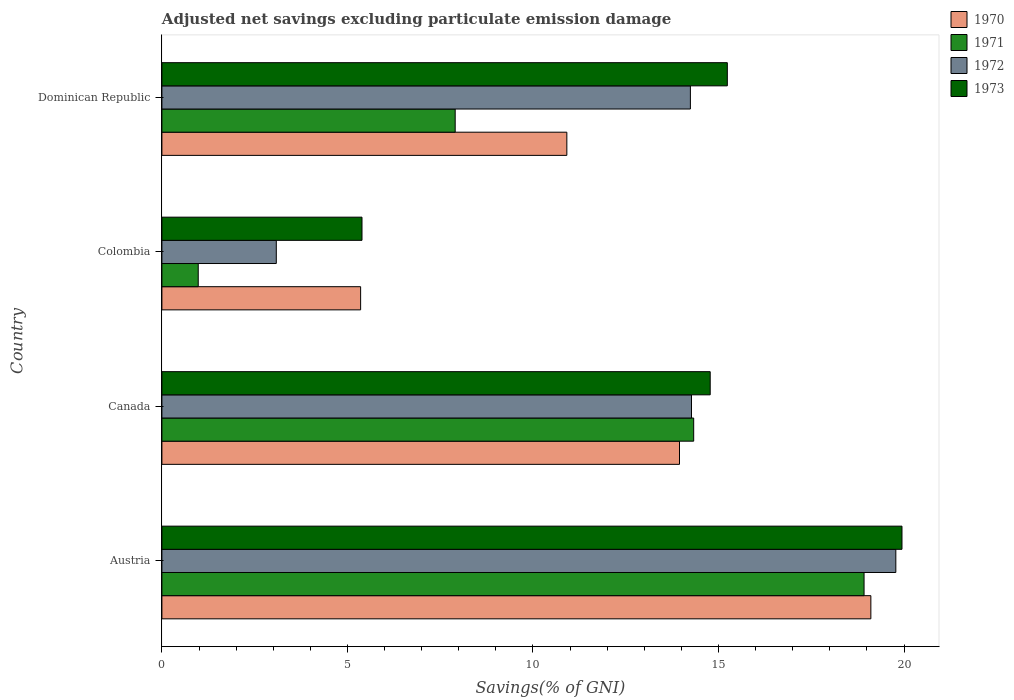How many different coloured bars are there?
Make the answer very short. 4. How many groups of bars are there?
Keep it short and to the point. 4. Are the number of bars per tick equal to the number of legend labels?
Make the answer very short. Yes. Are the number of bars on each tick of the Y-axis equal?
Offer a very short reply. Yes. How many bars are there on the 1st tick from the bottom?
Your answer should be compact. 4. What is the adjusted net savings in 1973 in Dominican Republic?
Keep it short and to the point. 15.24. Across all countries, what is the maximum adjusted net savings in 1971?
Provide a succinct answer. 18.92. Across all countries, what is the minimum adjusted net savings in 1972?
Your answer should be compact. 3.08. What is the total adjusted net savings in 1973 in the graph?
Offer a terse response. 55.35. What is the difference between the adjusted net savings in 1972 in Austria and that in Dominican Republic?
Provide a succinct answer. 5.54. What is the difference between the adjusted net savings in 1971 in Dominican Republic and the adjusted net savings in 1970 in Austria?
Your answer should be compact. -11.2. What is the average adjusted net savings in 1971 per country?
Ensure brevity in your answer.  10.53. What is the difference between the adjusted net savings in 1973 and adjusted net savings in 1970 in Austria?
Give a very brief answer. 0.84. In how many countries, is the adjusted net savings in 1972 greater than 12 %?
Keep it short and to the point. 3. What is the ratio of the adjusted net savings in 1972 in Canada to that in Colombia?
Offer a terse response. 4.63. Is the adjusted net savings in 1973 in Canada less than that in Dominican Republic?
Ensure brevity in your answer.  Yes. Is the difference between the adjusted net savings in 1973 in Canada and Colombia greater than the difference between the adjusted net savings in 1970 in Canada and Colombia?
Ensure brevity in your answer.  Yes. What is the difference between the highest and the second highest adjusted net savings in 1972?
Provide a succinct answer. 5.51. What is the difference between the highest and the lowest adjusted net savings in 1971?
Your answer should be compact. 17.94. Is the sum of the adjusted net savings in 1971 in Canada and Dominican Republic greater than the maximum adjusted net savings in 1972 across all countries?
Give a very brief answer. Yes. Is it the case that in every country, the sum of the adjusted net savings in 1970 and adjusted net savings in 1972 is greater than the sum of adjusted net savings in 1971 and adjusted net savings in 1973?
Your response must be concise. No. What does the 3rd bar from the top in Colombia represents?
Your answer should be very brief. 1971. What does the 3rd bar from the bottom in Dominican Republic represents?
Make the answer very short. 1972. How many bars are there?
Offer a very short reply. 16. Are all the bars in the graph horizontal?
Offer a very short reply. Yes. How many countries are there in the graph?
Give a very brief answer. 4. Are the values on the major ticks of X-axis written in scientific E-notation?
Make the answer very short. No. Does the graph contain any zero values?
Your response must be concise. No. Where does the legend appear in the graph?
Offer a terse response. Top right. What is the title of the graph?
Make the answer very short. Adjusted net savings excluding particulate emission damage. What is the label or title of the X-axis?
Ensure brevity in your answer.  Savings(% of GNI). What is the label or title of the Y-axis?
Offer a very short reply. Country. What is the Savings(% of GNI) of 1970 in Austria?
Provide a short and direct response. 19.11. What is the Savings(% of GNI) in 1971 in Austria?
Your answer should be very brief. 18.92. What is the Savings(% of GNI) of 1972 in Austria?
Offer a terse response. 19.78. What is the Savings(% of GNI) of 1973 in Austria?
Your answer should be compact. 19.94. What is the Savings(% of GNI) in 1970 in Canada?
Provide a succinct answer. 13.95. What is the Savings(% of GNI) of 1971 in Canada?
Ensure brevity in your answer.  14.33. What is the Savings(% of GNI) in 1972 in Canada?
Your response must be concise. 14.27. What is the Savings(% of GNI) in 1973 in Canada?
Your answer should be compact. 14.78. What is the Savings(% of GNI) in 1970 in Colombia?
Ensure brevity in your answer.  5.36. What is the Savings(% of GNI) in 1971 in Colombia?
Give a very brief answer. 0.98. What is the Savings(% of GNI) in 1972 in Colombia?
Ensure brevity in your answer.  3.08. What is the Savings(% of GNI) of 1973 in Colombia?
Offer a very short reply. 5.39. What is the Savings(% of GNI) of 1970 in Dominican Republic?
Provide a succinct answer. 10.91. What is the Savings(% of GNI) in 1971 in Dominican Republic?
Your answer should be compact. 7.9. What is the Savings(% of GNI) in 1972 in Dominican Republic?
Your response must be concise. 14.24. What is the Savings(% of GNI) in 1973 in Dominican Republic?
Your answer should be compact. 15.24. Across all countries, what is the maximum Savings(% of GNI) in 1970?
Your response must be concise. 19.11. Across all countries, what is the maximum Savings(% of GNI) in 1971?
Give a very brief answer. 18.92. Across all countries, what is the maximum Savings(% of GNI) in 1972?
Your answer should be very brief. 19.78. Across all countries, what is the maximum Savings(% of GNI) in 1973?
Ensure brevity in your answer.  19.94. Across all countries, what is the minimum Savings(% of GNI) of 1970?
Keep it short and to the point. 5.36. Across all countries, what is the minimum Savings(% of GNI) in 1971?
Give a very brief answer. 0.98. Across all countries, what is the minimum Savings(% of GNI) of 1972?
Provide a short and direct response. 3.08. Across all countries, what is the minimum Savings(% of GNI) in 1973?
Provide a short and direct response. 5.39. What is the total Savings(% of GNI) of 1970 in the graph?
Make the answer very short. 49.32. What is the total Savings(% of GNI) of 1971 in the graph?
Your answer should be very brief. 42.14. What is the total Savings(% of GNI) in 1972 in the graph?
Keep it short and to the point. 51.38. What is the total Savings(% of GNI) of 1973 in the graph?
Keep it short and to the point. 55.35. What is the difference between the Savings(% of GNI) in 1970 in Austria and that in Canada?
Your response must be concise. 5.16. What is the difference between the Savings(% of GNI) in 1971 in Austria and that in Canada?
Offer a very short reply. 4.59. What is the difference between the Savings(% of GNI) of 1972 in Austria and that in Canada?
Ensure brevity in your answer.  5.51. What is the difference between the Savings(% of GNI) of 1973 in Austria and that in Canada?
Your answer should be very brief. 5.17. What is the difference between the Savings(% of GNI) in 1970 in Austria and that in Colombia?
Provide a short and direct response. 13.75. What is the difference between the Savings(% of GNI) in 1971 in Austria and that in Colombia?
Keep it short and to the point. 17.94. What is the difference between the Savings(% of GNI) of 1972 in Austria and that in Colombia?
Ensure brevity in your answer.  16.7. What is the difference between the Savings(% of GNI) of 1973 in Austria and that in Colombia?
Offer a very short reply. 14.55. What is the difference between the Savings(% of GNI) in 1970 in Austria and that in Dominican Republic?
Make the answer very short. 8.19. What is the difference between the Savings(% of GNI) in 1971 in Austria and that in Dominican Republic?
Offer a terse response. 11.02. What is the difference between the Savings(% of GNI) of 1972 in Austria and that in Dominican Republic?
Your answer should be very brief. 5.54. What is the difference between the Savings(% of GNI) of 1973 in Austria and that in Dominican Republic?
Your answer should be compact. 4.71. What is the difference between the Savings(% of GNI) in 1970 in Canada and that in Colombia?
Your response must be concise. 8.59. What is the difference between the Savings(% of GNI) of 1971 in Canada and that in Colombia?
Keep it short and to the point. 13.35. What is the difference between the Savings(% of GNI) of 1972 in Canada and that in Colombia?
Offer a very short reply. 11.19. What is the difference between the Savings(% of GNI) in 1973 in Canada and that in Colombia?
Provide a succinct answer. 9.38. What is the difference between the Savings(% of GNI) in 1970 in Canada and that in Dominican Republic?
Your answer should be compact. 3.04. What is the difference between the Savings(% of GNI) in 1971 in Canada and that in Dominican Republic?
Provide a succinct answer. 6.43. What is the difference between the Savings(% of GNI) of 1972 in Canada and that in Dominican Republic?
Your response must be concise. 0.03. What is the difference between the Savings(% of GNI) of 1973 in Canada and that in Dominican Republic?
Your answer should be compact. -0.46. What is the difference between the Savings(% of GNI) of 1970 in Colombia and that in Dominican Republic?
Ensure brevity in your answer.  -5.56. What is the difference between the Savings(% of GNI) of 1971 in Colombia and that in Dominican Republic?
Provide a short and direct response. -6.92. What is the difference between the Savings(% of GNI) in 1972 in Colombia and that in Dominican Republic?
Your response must be concise. -11.16. What is the difference between the Savings(% of GNI) in 1973 in Colombia and that in Dominican Republic?
Offer a terse response. -9.85. What is the difference between the Savings(% of GNI) of 1970 in Austria and the Savings(% of GNI) of 1971 in Canada?
Keep it short and to the point. 4.77. What is the difference between the Savings(% of GNI) of 1970 in Austria and the Savings(% of GNI) of 1972 in Canada?
Make the answer very short. 4.83. What is the difference between the Savings(% of GNI) of 1970 in Austria and the Savings(% of GNI) of 1973 in Canada?
Your response must be concise. 4.33. What is the difference between the Savings(% of GNI) in 1971 in Austria and the Savings(% of GNI) in 1972 in Canada?
Offer a very short reply. 4.65. What is the difference between the Savings(% of GNI) of 1971 in Austria and the Savings(% of GNI) of 1973 in Canada?
Ensure brevity in your answer.  4.15. What is the difference between the Savings(% of GNI) in 1972 in Austria and the Savings(% of GNI) in 1973 in Canada?
Keep it short and to the point. 5. What is the difference between the Savings(% of GNI) of 1970 in Austria and the Savings(% of GNI) of 1971 in Colombia?
Give a very brief answer. 18.13. What is the difference between the Savings(% of GNI) of 1970 in Austria and the Savings(% of GNI) of 1972 in Colombia?
Make the answer very short. 16.02. What is the difference between the Savings(% of GNI) in 1970 in Austria and the Savings(% of GNI) in 1973 in Colombia?
Your answer should be compact. 13.71. What is the difference between the Savings(% of GNI) in 1971 in Austria and the Savings(% of GNI) in 1972 in Colombia?
Your answer should be compact. 15.84. What is the difference between the Savings(% of GNI) in 1971 in Austria and the Savings(% of GNI) in 1973 in Colombia?
Your response must be concise. 13.53. What is the difference between the Savings(% of GNI) of 1972 in Austria and the Savings(% of GNI) of 1973 in Colombia?
Ensure brevity in your answer.  14.39. What is the difference between the Savings(% of GNI) of 1970 in Austria and the Savings(% of GNI) of 1971 in Dominican Republic?
Keep it short and to the point. 11.2. What is the difference between the Savings(% of GNI) of 1970 in Austria and the Savings(% of GNI) of 1972 in Dominican Republic?
Give a very brief answer. 4.86. What is the difference between the Savings(% of GNI) of 1970 in Austria and the Savings(% of GNI) of 1973 in Dominican Republic?
Your answer should be compact. 3.87. What is the difference between the Savings(% of GNI) in 1971 in Austria and the Savings(% of GNI) in 1972 in Dominican Republic?
Ensure brevity in your answer.  4.68. What is the difference between the Savings(% of GNI) in 1971 in Austria and the Savings(% of GNI) in 1973 in Dominican Republic?
Make the answer very short. 3.68. What is the difference between the Savings(% of GNI) in 1972 in Austria and the Savings(% of GNI) in 1973 in Dominican Republic?
Your response must be concise. 4.54. What is the difference between the Savings(% of GNI) of 1970 in Canada and the Savings(% of GNI) of 1971 in Colombia?
Provide a short and direct response. 12.97. What is the difference between the Savings(% of GNI) in 1970 in Canada and the Savings(% of GNI) in 1972 in Colombia?
Make the answer very short. 10.87. What is the difference between the Savings(% of GNI) of 1970 in Canada and the Savings(% of GNI) of 1973 in Colombia?
Give a very brief answer. 8.56. What is the difference between the Savings(% of GNI) in 1971 in Canada and the Savings(% of GNI) in 1972 in Colombia?
Your answer should be compact. 11.25. What is the difference between the Savings(% of GNI) of 1971 in Canada and the Savings(% of GNI) of 1973 in Colombia?
Your answer should be very brief. 8.94. What is the difference between the Savings(% of GNI) of 1972 in Canada and the Savings(% of GNI) of 1973 in Colombia?
Your response must be concise. 8.88. What is the difference between the Savings(% of GNI) in 1970 in Canada and the Savings(% of GNI) in 1971 in Dominican Republic?
Give a very brief answer. 6.05. What is the difference between the Savings(% of GNI) of 1970 in Canada and the Savings(% of GNI) of 1972 in Dominican Republic?
Your response must be concise. -0.29. What is the difference between the Savings(% of GNI) of 1970 in Canada and the Savings(% of GNI) of 1973 in Dominican Republic?
Give a very brief answer. -1.29. What is the difference between the Savings(% of GNI) of 1971 in Canada and the Savings(% of GNI) of 1972 in Dominican Republic?
Ensure brevity in your answer.  0.09. What is the difference between the Savings(% of GNI) of 1971 in Canada and the Savings(% of GNI) of 1973 in Dominican Republic?
Keep it short and to the point. -0.91. What is the difference between the Savings(% of GNI) in 1972 in Canada and the Savings(% of GNI) in 1973 in Dominican Republic?
Keep it short and to the point. -0.97. What is the difference between the Savings(% of GNI) of 1970 in Colombia and the Savings(% of GNI) of 1971 in Dominican Republic?
Give a very brief answer. -2.55. What is the difference between the Savings(% of GNI) in 1970 in Colombia and the Savings(% of GNI) in 1972 in Dominican Republic?
Offer a very short reply. -8.89. What is the difference between the Savings(% of GNI) in 1970 in Colombia and the Savings(% of GNI) in 1973 in Dominican Republic?
Offer a very short reply. -9.88. What is the difference between the Savings(% of GNI) in 1971 in Colombia and the Savings(% of GNI) in 1972 in Dominican Republic?
Your answer should be very brief. -13.26. What is the difference between the Savings(% of GNI) in 1971 in Colombia and the Savings(% of GNI) in 1973 in Dominican Republic?
Offer a terse response. -14.26. What is the difference between the Savings(% of GNI) in 1972 in Colombia and the Savings(% of GNI) in 1973 in Dominican Republic?
Offer a terse response. -12.15. What is the average Savings(% of GNI) of 1970 per country?
Offer a very short reply. 12.33. What is the average Savings(% of GNI) in 1971 per country?
Keep it short and to the point. 10.53. What is the average Savings(% of GNI) of 1972 per country?
Make the answer very short. 12.84. What is the average Savings(% of GNI) in 1973 per country?
Your answer should be compact. 13.84. What is the difference between the Savings(% of GNI) in 1970 and Savings(% of GNI) in 1971 in Austria?
Offer a terse response. 0.18. What is the difference between the Savings(% of GNI) of 1970 and Savings(% of GNI) of 1972 in Austria?
Your response must be concise. -0.67. What is the difference between the Savings(% of GNI) of 1970 and Savings(% of GNI) of 1973 in Austria?
Your answer should be very brief. -0.84. What is the difference between the Savings(% of GNI) in 1971 and Savings(% of GNI) in 1972 in Austria?
Make the answer very short. -0.86. What is the difference between the Savings(% of GNI) in 1971 and Savings(% of GNI) in 1973 in Austria?
Offer a very short reply. -1.02. What is the difference between the Savings(% of GNI) in 1972 and Savings(% of GNI) in 1973 in Austria?
Offer a very short reply. -0.17. What is the difference between the Savings(% of GNI) in 1970 and Savings(% of GNI) in 1971 in Canada?
Keep it short and to the point. -0.38. What is the difference between the Savings(% of GNI) of 1970 and Savings(% of GNI) of 1972 in Canada?
Make the answer very short. -0.32. What is the difference between the Savings(% of GNI) in 1970 and Savings(% of GNI) in 1973 in Canada?
Provide a succinct answer. -0.83. What is the difference between the Savings(% of GNI) of 1971 and Savings(% of GNI) of 1972 in Canada?
Provide a short and direct response. 0.06. What is the difference between the Savings(% of GNI) in 1971 and Savings(% of GNI) in 1973 in Canada?
Your response must be concise. -0.45. What is the difference between the Savings(% of GNI) of 1972 and Savings(% of GNI) of 1973 in Canada?
Your answer should be very brief. -0.5. What is the difference between the Savings(% of GNI) in 1970 and Savings(% of GNI) in 1971 in Colombia?
Make the answer very short. 4.38. What is the difference between the Savings(% of GNI) in 1970 and Savings(% of GNI) in 1972 in Colombia?
Provide a succinct answer. 2.27. What is the difference between the Savings(% of GNI) in 1970 and Savings(% of GNI) in 1973 in Colombia?
Your answer should be very brief. -0.04. What is the difference between the Savings(% of GNI) of 1971 and Savings(% of GNI) of 1972 in Colombia?
Your answer should be very brief. -2.1. What is the difference between the Savings(% of GNI) in 1971 and Savings(% of GNI) in 1973 in Colombia?
Provide a succinct answer. -4.41. What is the difference between the Savings(% of GNI) in 1972 and Savings(% of GNI) in 1973 in Colombia?
Make the answer very short. -2.31. What is the difference between the Savings(% of GNI) in 1970 and Savings(% of GNI) in 1971 in Dominican Republic?
Provide a succinct answer. 3.01. What is the difference between the Savings(% of GNI) in 1970 and Savings(% of GNI) in 1972 in Dominican Republic?
Ensure brevity in your answer.  -3.33. What is the difference between the Savings(% of GNI) in 1970 and Savings(% of GNI) in 1973 in Dominican Republic?
Your response must be concise. -4.33. What is the difference between the Savings(% of GNI) of 1971 and Savings(% of GNI) of 1972 in Dominican Republic?
Your response must be concise. -6.34. What is the difference between the Savings(% of GNI) in 1971 and Savings(% of GNI) in 1973 in Dominican Republic?
Provide a succinct answer. -7.33. What is the difference between the Savings(% of GNI) in 1972 and Savings(% of GNI) in 1973 in Dominican Republic?
Ensure brevity in your answer.  -1. What is the ratio of the Savings(% of GNI) in 1970 in Austria to that in Canada?
Offer a terse response. 1.37. What is the ratio of the Savings(% of GNI) of 1971 in Austria to that in Canada?
Ensure brevity in your answer.  1.32. What is the ratio of the Savings(% of GNI) of 1972 in Austria to that in Canada?
Keep it short and to the point. 1.39. What is the ratio of the Savings(% of GNI) of 1973 in Austria to that in Canada?
Provide a short and direct response. 1.35. What is the ratio of the Savings(% of GNI) in 1970 in Austria to that in Colombia?
Ensure brevity in your answer.  3.57. What is the ratio of the Savings(% of GNI) of 1971 in Austria to that in Colombia?
Your response must be concise. 19.32. What is the ratio of the Savings(% of GNI) in 1972 in Austria to that in Colombia?
Ensure brevity in your answer.  6.42. What is the ratio of the Savings(% of GNI) of 1973 in Austria to that in Colombia?
Your answer should be very brief. 3.7. What is the ratio of the Savings(% of GNI) of 1970 in Austria to that in Dominican Republic?
Make the answer very short. 1.75. What is the ratio of the Savings(% of GNI) of 1971 in Austria to that in Dominican Republic?
Provide a succinct answer. 2.39. What is the ratio of the Savings(% of GNI) in 1972 in Austria to that in Dominican Republic?
Give a very brief answer. 1.39. What is the ratio of the Savings(% of GNI) in 1973 in Austria to that in Dominican Republic?
Your response must be concise. 1.31. What is the ratio of the Savings(% of GNI) of 1970 in Canada to that in Colombia?
Give a very brief answer. 2.6. What is the ratio of the Savings(% of GNI) in 1971 in Canada to that in Colombia?
Keep it short and to the point. 14.64. What is the ratio of the Savings(% of GNI) of 1972 in Canada to that in Colombia?
Offer a very short reply. 4.63. What is the ratio of the Savings(% of GNI) in 1973 in Canada to that in Colombia?
Your response must be concise. 2.74. What is the ratio of the Savings(% of GNI) in 1970 in Canada to that in Dominican Republic?
Ensure brevity in your answer.  1.28. What is the ratio of the Savings(% of GNI) in 1971 in Canada to that in Dominican Republic?
Your response must be concise. 1.81. What is the ratio of the Savings(% of GNI) in 1972 in Canada to that in Dominican Republic?
Keep it short and to the point. 1. What is the ratio of the Savings(% of GNI) of 1973 in Canada to that in Dominican Republic?
Make the answer very short. 0.97. What is the ratio of the Savings(% of GNI) of 1970 in Colombia to that in Dominican Republic?
Provide a short and direct response. 0.49. What is the ratio of the Savings(% of GNI) of 1971 in Colombia to that in Dominican Republic?
Your answer should be compact. 0.12. What is the ratio of the Savings(% of GNI) of 1972 in Colombia to that in Dominican Republic?
Your answer should be very brief. 0.22. What is the ratio of the Savings(% of GNI) in 1973 in Colombia to that in Dominican Republic?
Your response must be concise. 0.35. What is the difference between the highest and the second highest Savings(% of GNI) of 1970?
Make the answer very short. 5.16. What is the difference between the highest and the second highest Savings(% of GNI) in 1971?
Ensure brevity in your answer.  4.59. What is the difference between the highest and the second highest Savings(% of GNI) in 1972?
Your answer should be very brief. 5.51. What is the difference between the highest and the second highest Savings(% of GNI) of 1973?
Your answer should be very brief. 4.71. What is the difference between the highest and the lowest Savings(% of GNI) of 1970?
Offer a very short reply. 13.75. What is the difference between the highest and the lowest Savings(% of GNI) in 1971?
Provide a succinct answer. 17.94. What is the difference between the highest and the lowest Savings(% of GNI) of 1972?
Give a very brief answer. 16.7. What is the difference between the highest and the lowest Savings(% of GNI) in 1973?
Provide a succinct answer. 14.55. 